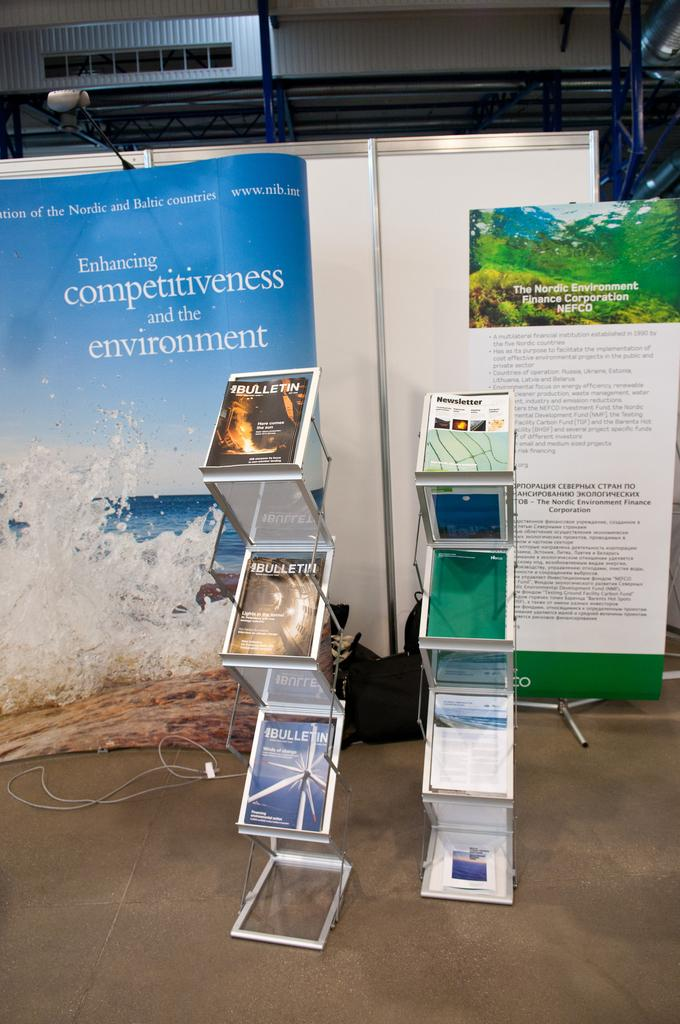What type of objects are present in the image that are used for holding items? There are two metal stands in the image that are used for holding items. What items are placed on the metal stands? There are books on the metal stands. What can be seen in the background of the image? In the background of the image, there are banners, wires, metal rods, and a building. What type of pest can be seen crawling on the books in the image? There are no pests visible in the image; it only shows metal stands with books and the background elements. 